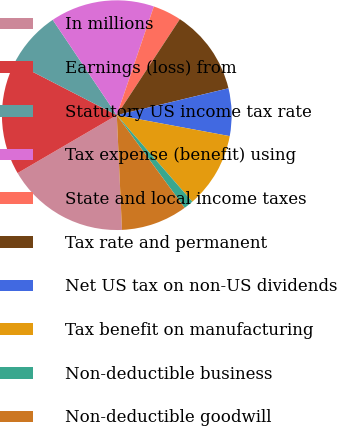Convert chart to OTSL. <chart><loc_0><loc_0><loc_500><loc_500><pie_chart><fcel>In millions<fcel>Earnings (loss) from<fcel>Statutory US income tax rate<fcel>Tax expense (benefit) using<fcel>State and local income taxes<fcel>Tax rate and permanent<fcel>Net US tax on non-US dividends<fcel>Tax benefit on manufacturing<fcel>Non-deductible business<fcel>Non-deductible goodwill<nl><fcel>17.31%<fcel>15.98%<fcel>8.01%<fcel>14.65%<fcel>4.02%<fcel>11.99%<fcel>6.68%<fcel>10.66%<fcel>1.36%<fcel>9.34%<nl></chart> 